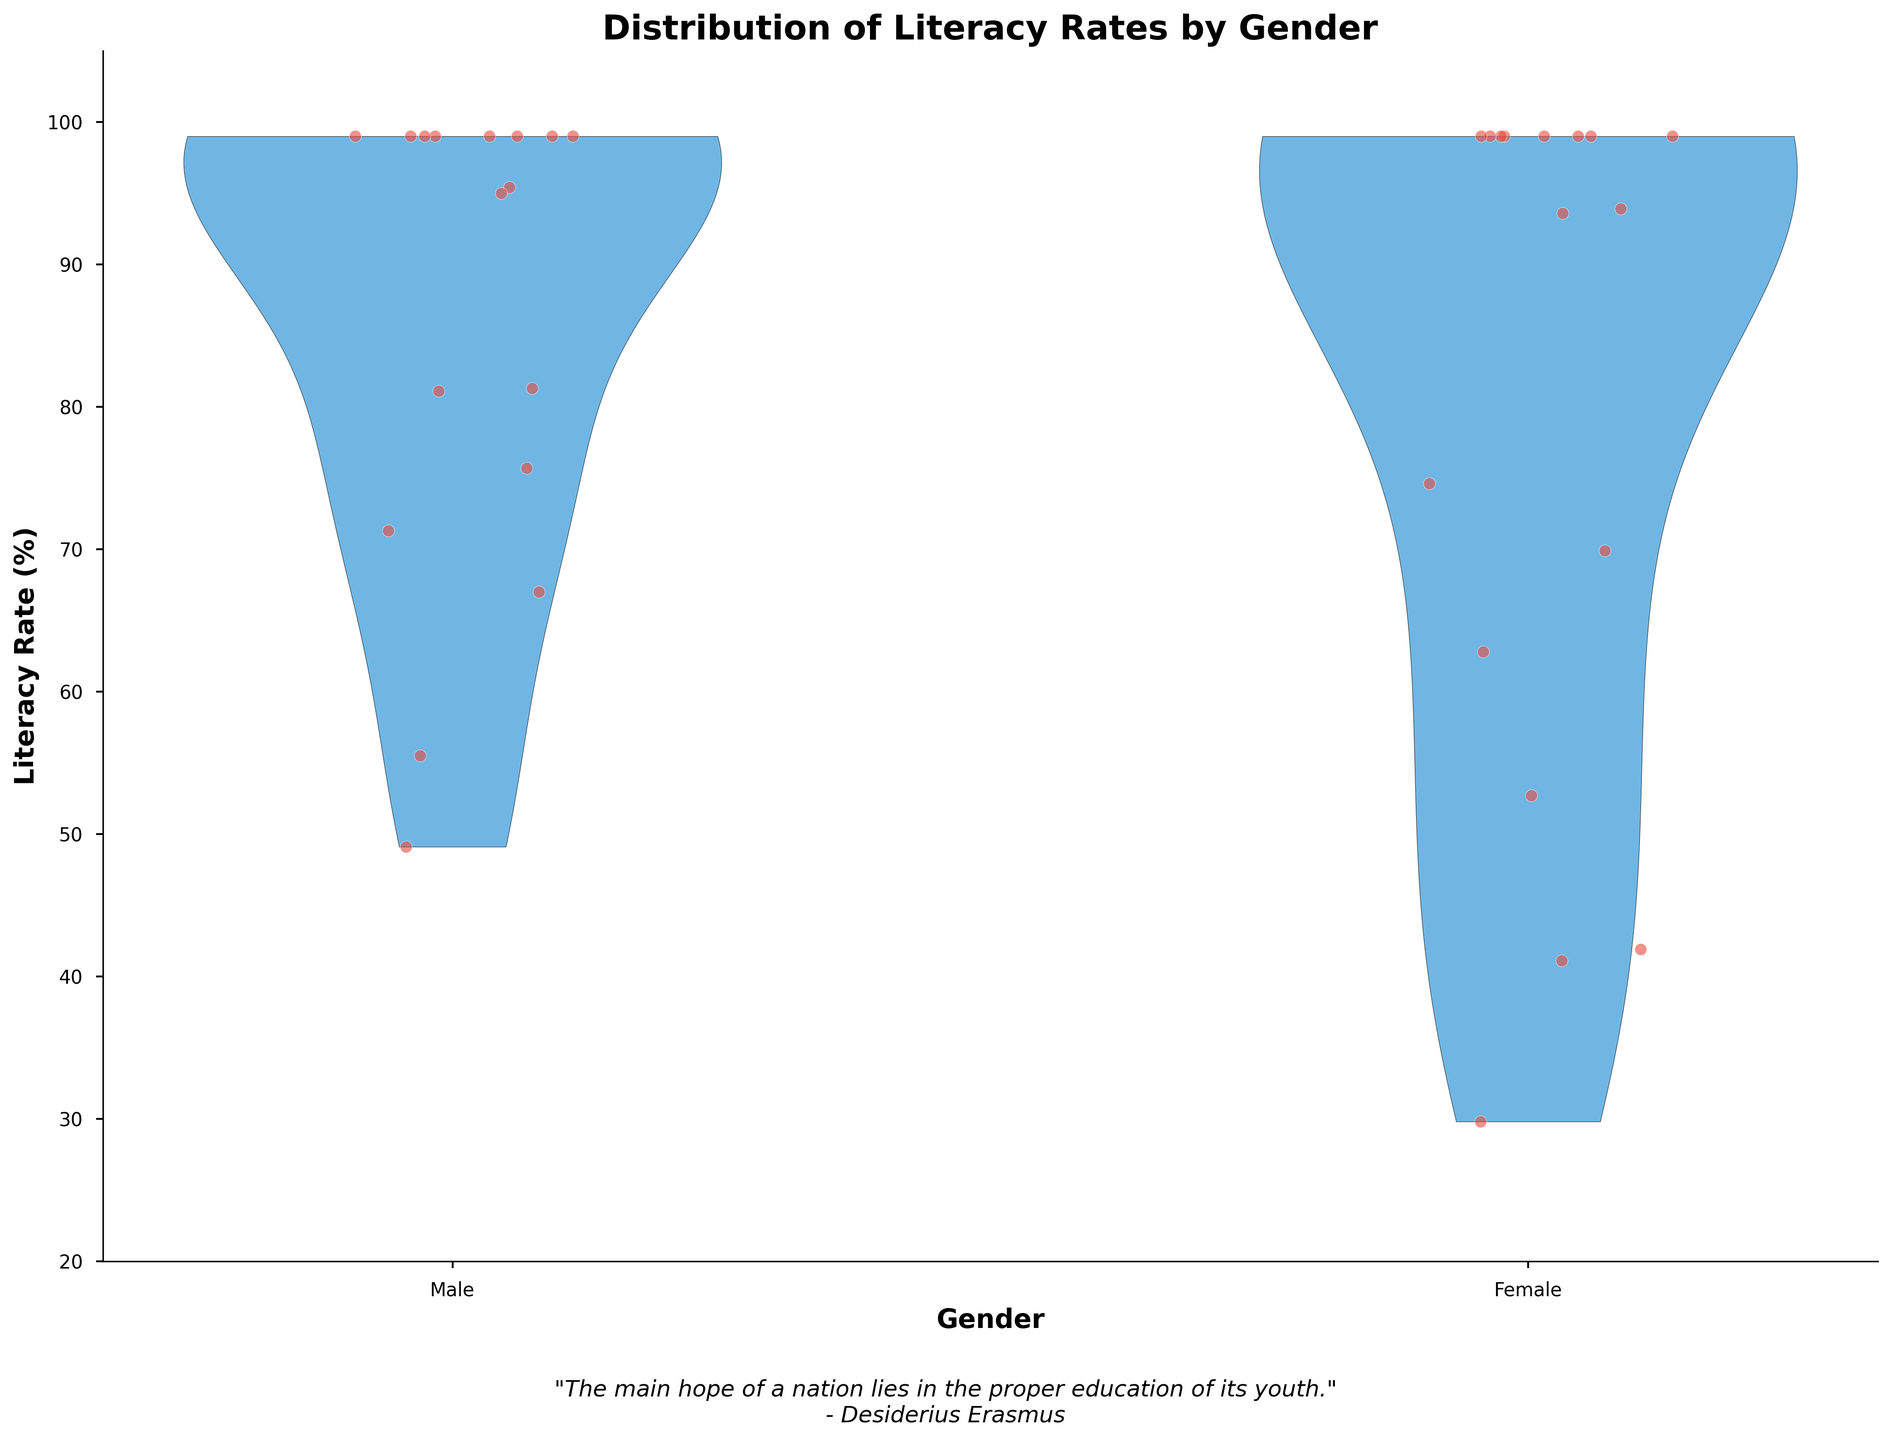What is the title of the plot? The title is located at the top of the plot. It reads "Distribution of Literacy Rates by Gender”.
Answer: Distribution of Literacy Rates by Gender Which gender has a wider distribution of literacy rates? The violin plot shows that the distribution for male literacy rates is wider compared to females, indicating more variation.
Answer: Male How does the literacy rate distribution for females compare to that of males? By observing the width of the violins, you can see that the female distribution is narrower, indicating less variation, while the male distribution appears wider.
Answer: Less varied What is the lowest observed literacy rate in the plot? The lowest observed literacy rate is situated on the y-axis around 30%, particularly noticeable in the female distribution.
Answer: Approximately 29.8% What is the range of literacy rates for males? The male literacy rates range from approximately 49.1% to 99.0%. This can be observed by looking at the left violin's spread along the y-axis.
Answer: 49.1% to 99.0% Are there any countries where male and female literacy rates are equal? The countries where the violins for both genders converge to the same points at the top, indicating equal literacy rates. These countries are Canada, Denmark, France, Germany, Japan, Norway, United Kingdom, and United States.
Answer: Yes Which gender has a higher literacy rate in Kenya? By looking at the positions of the scattered points, the male literacy rate in Kenya is higher (81.1%) compared to the female literacy rate (74.6%).
Answer: Male How do the literacy rates in Ethiopia compare across genders? Comparing the vertical position of data points for Ethiopia, males have a literacy rate of 49.1%, which is higher than females at 41.1%.
Answer: Males are higher Based on the visualization, which country's males have a literacy rate equal to females in Bangladesh? From the visualization and the scattered data points, both genders in Bangladesh have literacy rates in close range with males at 75.7% and females at 69.9%.
Answer: No males are equal to females' rate in Bangladesh What does the quote underneath the plot suggest about the importance of the data presented? The quote highlights the critical role of education in the progress of a nation, indicating the importance of literacy rates as shown in the plot.
Answer: Education is key to a nation's hope 